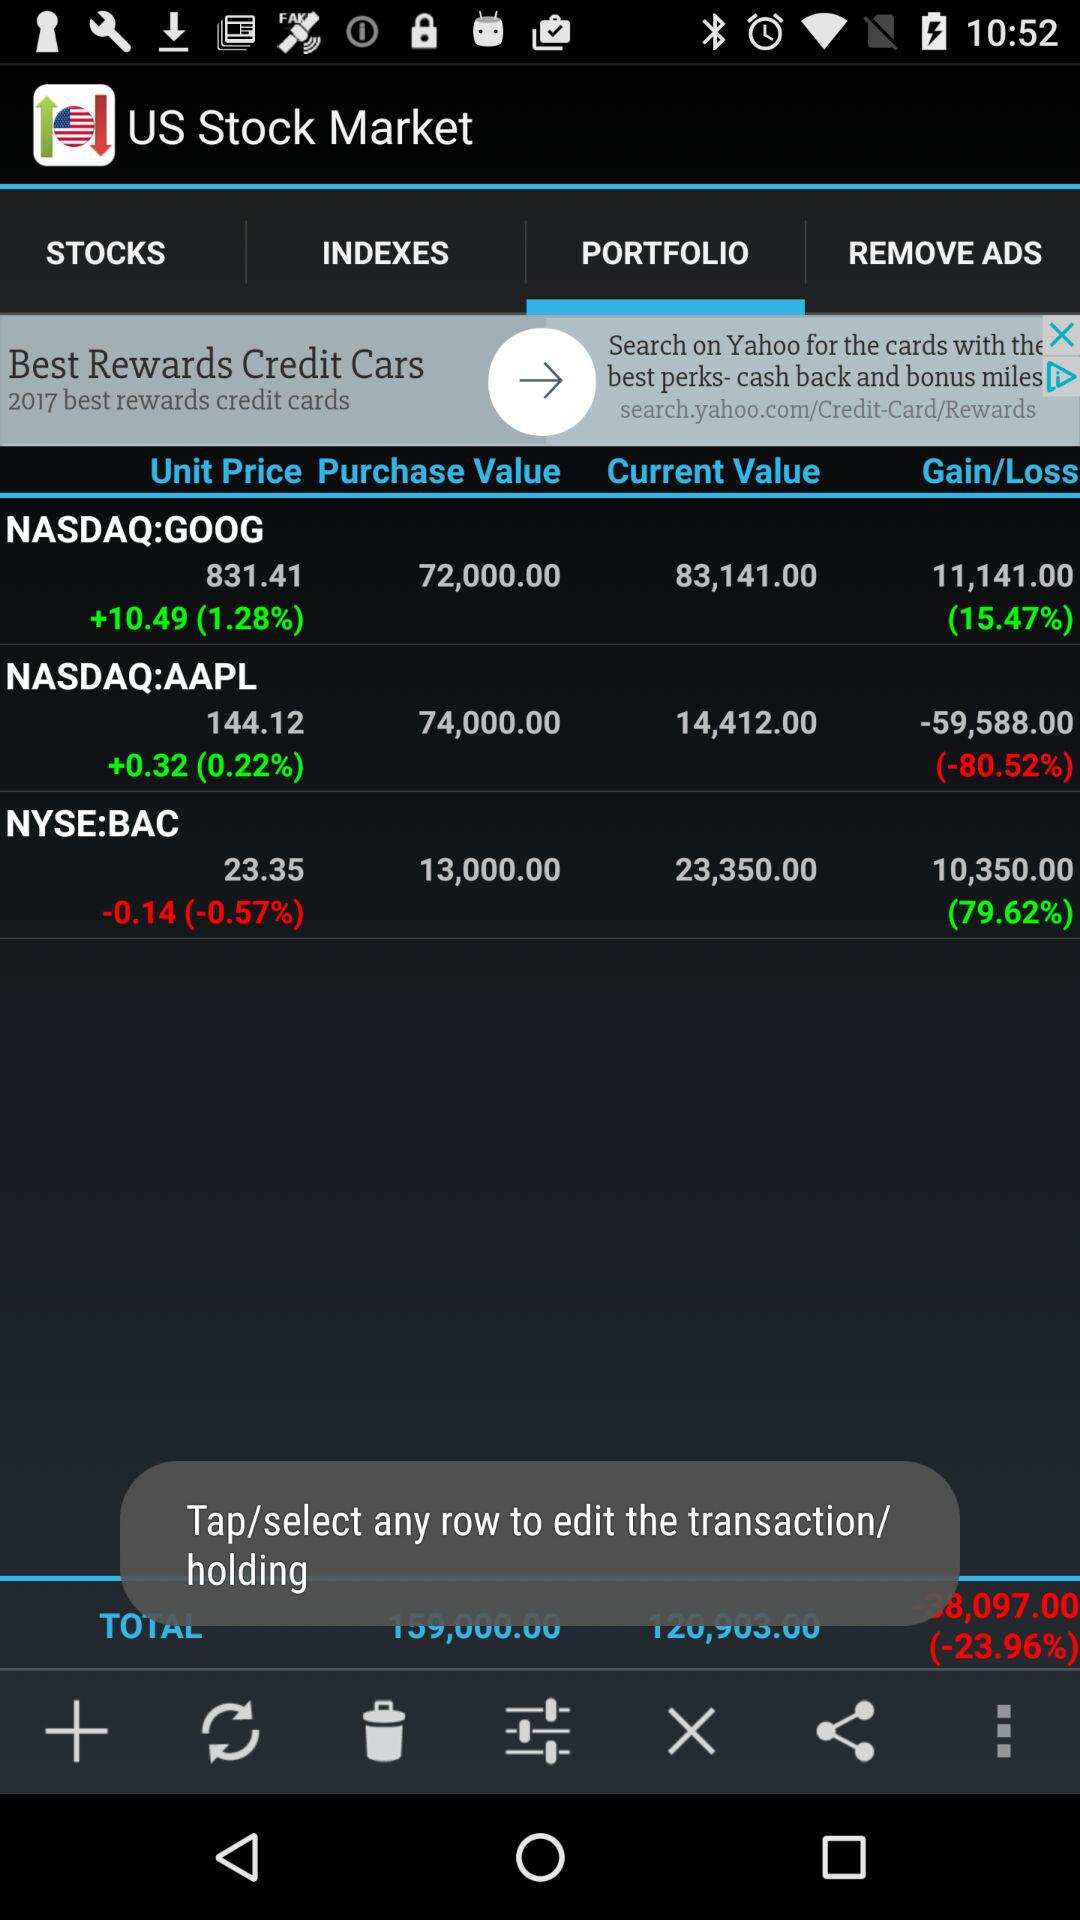What is the purchase value of NASDAQ:AAPL? The purchase value is 74,000. 